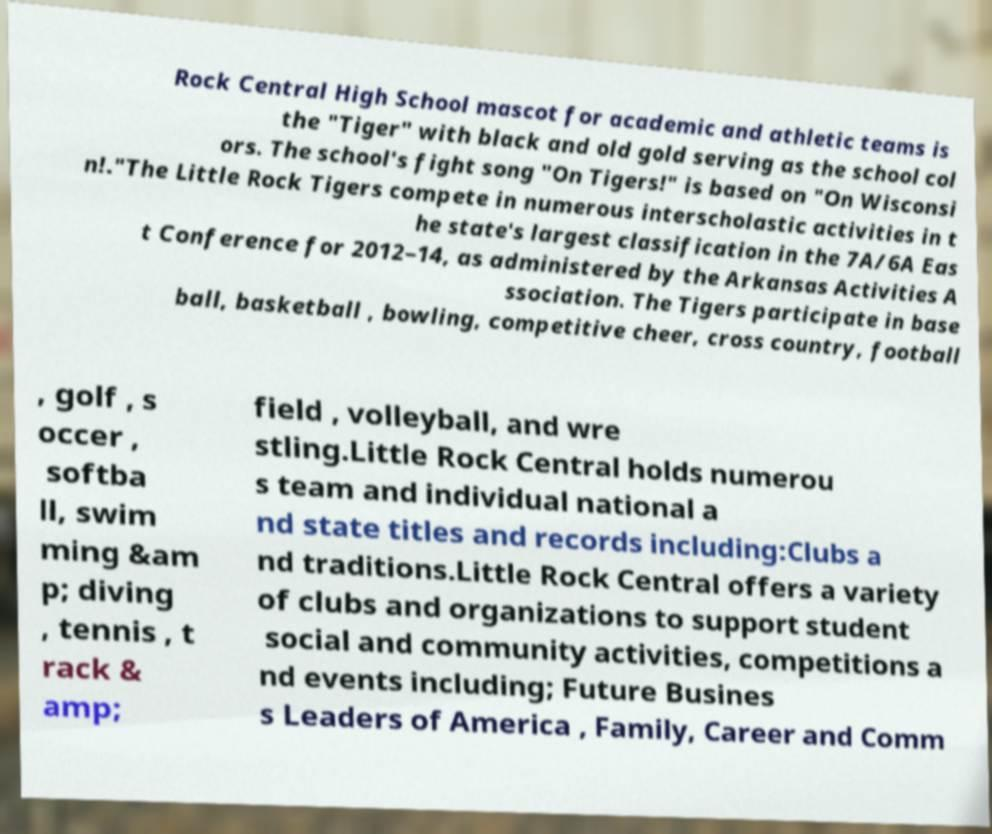Can you accurately transcribe the text from the provided image for me? Rock Central High School mascot for academic and athletic teams is the "Tiger" with black and old gold serving as the school col ors. The school's fight song "On Tigers!" is based on "On Wisconsi n!."The Little Rock Tigers compete in numerous interscholastic activities in t he state's largest classification in the 7A/6A Eas t Conference for 2012–14, as administered by the Arkansas Activities A ssociation. The Tigers participate in base ball, basketball , bowling, competitive cheer, cross country, football , golf , s occer , softba ll, swim ming &am p; diving , tennis , t rack & amp; field , volleyball, and wre stling.Little Rock Central holds numerou s team and individual national a nd state titles and records including:Clubs a nd traditions.Little Rock Central offers a variety of clubs and organizations to support student social and community activities, competitions a nd events including; Future Busines s Leaders of America , Family, Career and Comm 